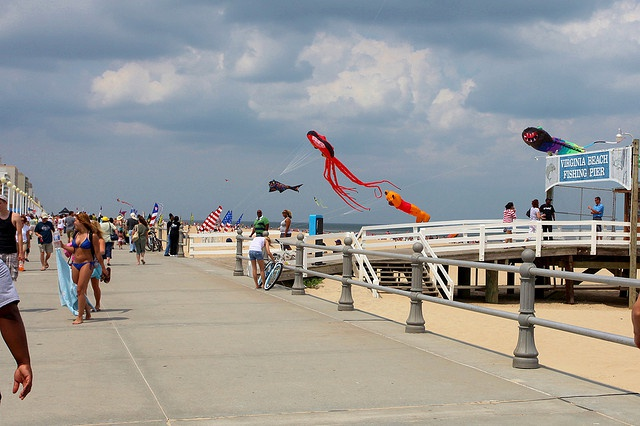Describe the objects in this image and their specific colors. I can see people in darkgray, black, lightgray, and gray tones, people in darkgray, black, maroon, and brown tones, people in darkgray, maroon, black, and brown tones, kite in darkgray and brown tones, and kite in darkgray, black, navy, and purple tones in this image. 